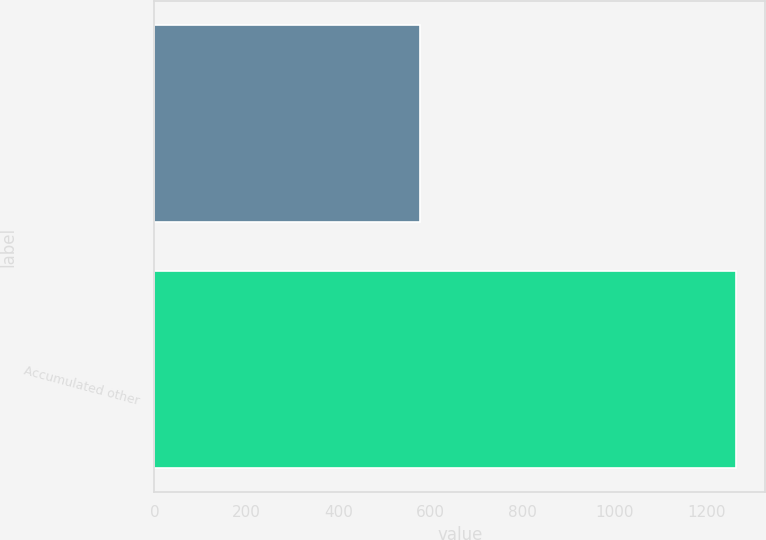Convert chart. <chart><loc_0><loc_0><loc_500><loc_500><bar_chart><ecel><fcel>Accumulated other<nl><fcel>577<fcel>1263<nl></chart> 